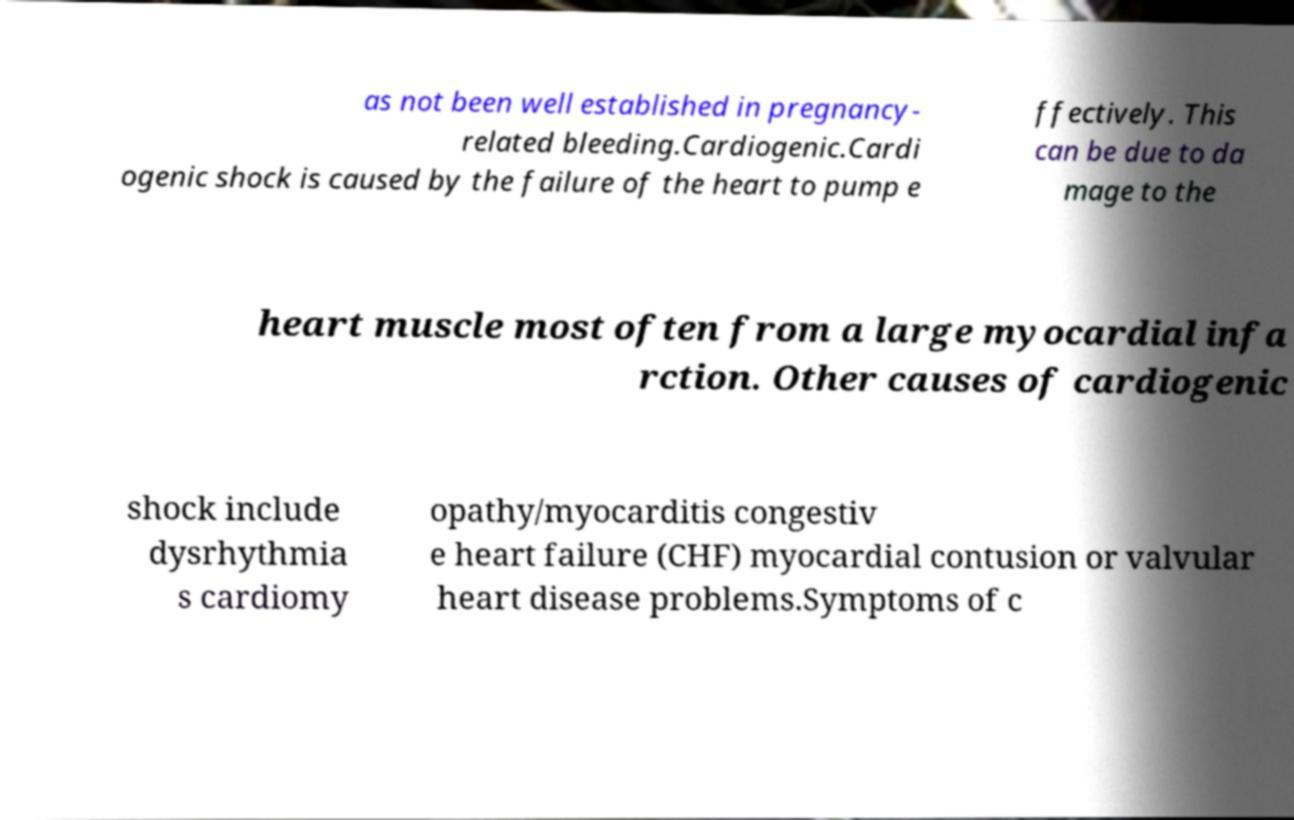There's text embedded in this image that I need extracted. Can you transcribe it verbatim? as not been well established in pregnancy- related bleeding.Cardiogenic.Cardi ogenic shock is caused by the failure of the heart to pump e ffectively. This can be due to da mage to the heart muscle most often from a large myocardial infa rction. Other causes of cardiogenic shock include dysrhythmia s cardiomy opathy/myocarditis congestiv e heart failure (CHF) myocardial contusion or valvular heart disease problems.Symptoms of c 